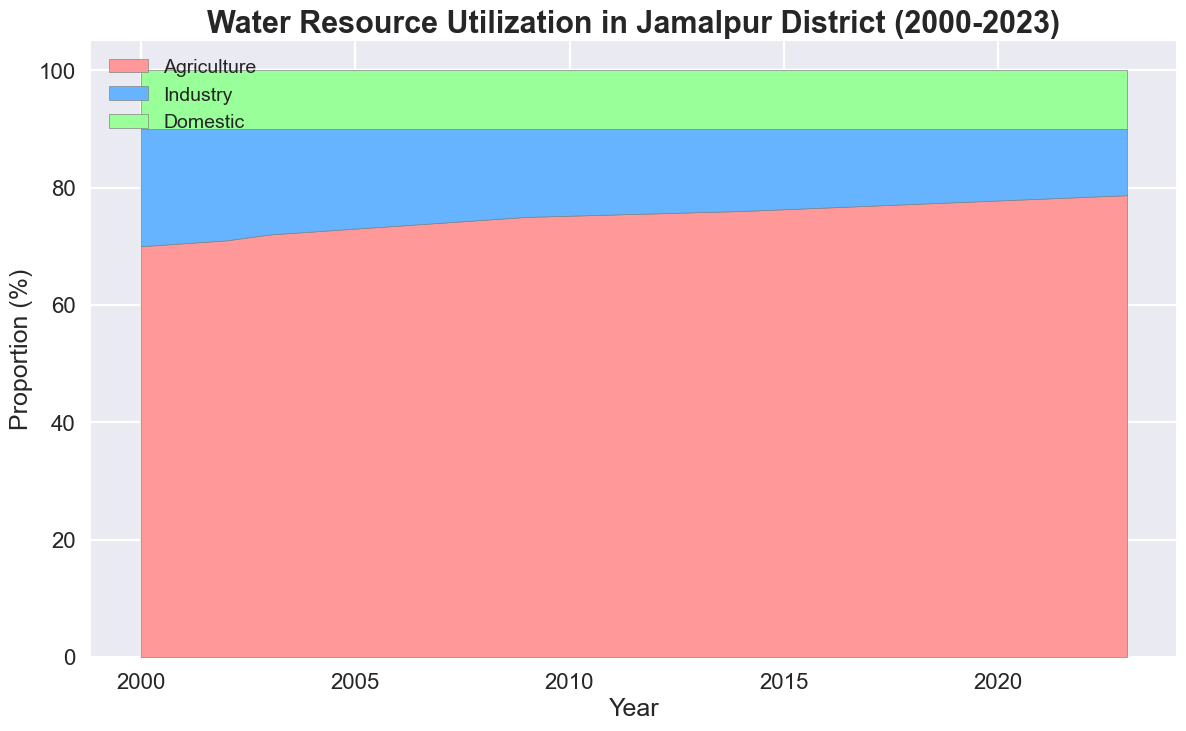What is the overall trend in water resource utilization for agriculture from 2000 to 2023? The area chart shows an increasing trend for agriculture from 70% in 2000 to 78.7% in 2023, indicating a consistent rise in water usage for agricultural purposes.
Answer: Increasing trend In which year did the proportion of water used for industry fall below 15%? By observing the area chart, in 2010 the water used for industry fell to 14.8%, marking the first year it dropped below 15%.
Answer: 2010 How has the proportion of water used for domestic purposes changed from 2000 to 2023? The area chart shows that the proportion of water used for domestic purposes has remained constant at 10% from 2000 to 2023.
Answer: No change What is the difference in the proportion of water used for agriculture between 2010 and 2023? In 2010, the proportion was 75.2%, and it increased to 78.7% by 2023. Thus, the difference is 78.7% - 75.2% = 3.5%.
Answer: 3.5% What is the sum of the proportions of water used for agriculture and industry in 2020? In 2020, the proportions are 77.8% for agriculture and 12.2% for industry. Summing them gives 77.8% + 12.2% = 90%.
Answer: 90% Between which years did the proportion of water used for agriculture increase the most? Observing the graph shows that from 2003 to 2004, the proportion saw an increase from 72% to 72.5%, indicating the largest yearly increase of 0.5%.
Answer: 2003 to 2004 Compare the visual proportion sizes of the agriculture and industry sections in 2015. Which is larger? In 2015, the area for agriculture is visually much larger than that for industry, reflecting their respective proportions of 76.3% and 13.7%.
Answer: Agriculture What is the average proportion of water used for domestic purposes over the entire period? The proportion of water used for domestic purposes remains constant at 10% from 2000 to 2023. Therefore, the average is simply 10%.
Answer: 10% Which sector showed a decreasing trend in water resource utilization from 2000 to 2023? By analyzing the area chart, the industry sector shows a clear decreasing trend, falling from 20% in 2000 to 11.3% in 2023.
Answer: Industry 